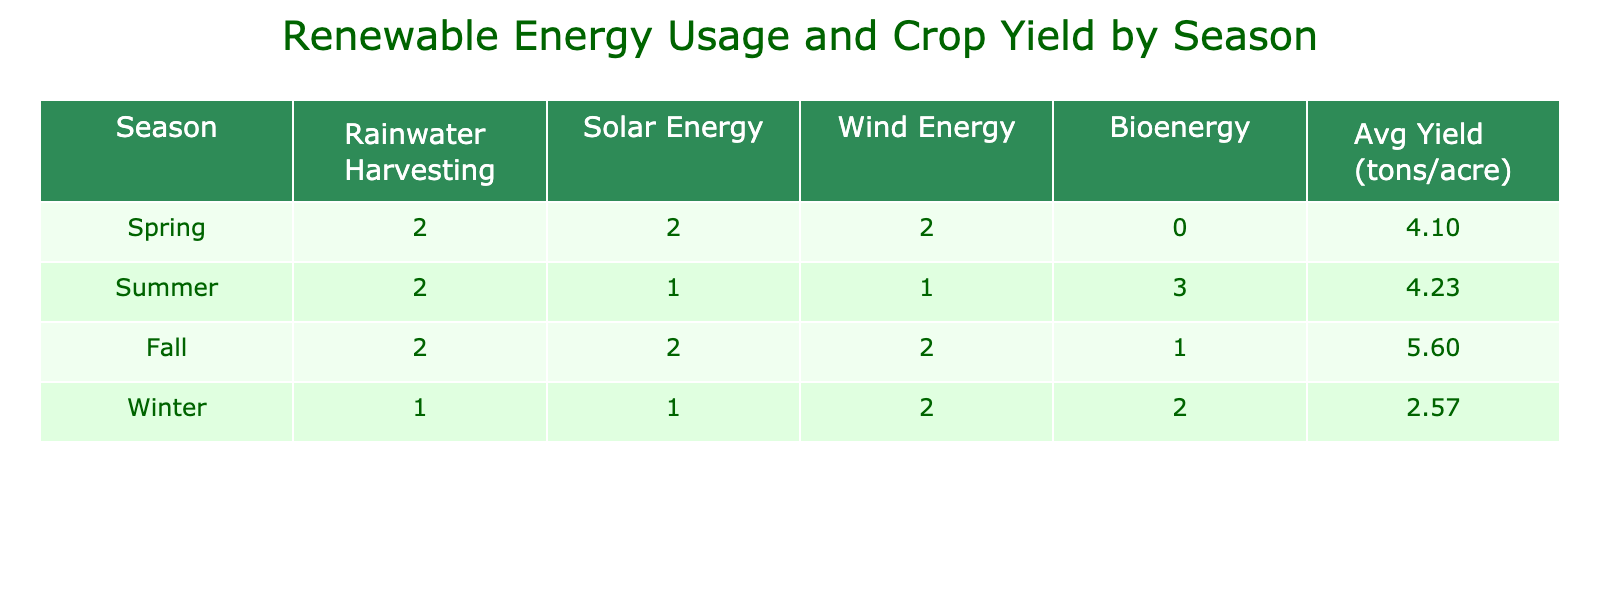What is the average crop yield in Spring? To find the average crop yield for Spring, we look at the crop yields for all Spring data points. The yields are 4.5, 3.8, and 4.0 tons per acre. Adding these values gives 4.5 + 3.8 + 4.0 = 12.3. Then, we divide by the number of data points (3) to find the average: 12.3 / 3 = 4.10.
Answer: 4.10 How many times was wind energy used in the Summer? To find the number of times wind energy was used in Summer, we examine the table for the Summer season. There are three data points for Summer: one with wind energy (in combination with other sources) and the other two without it. Thus, wind energy was used in just 1 combination, which is confirmed by checking each entry.
Answer: 1 Which season had the highest average crop yield? The average crop yields are calculated for each season: Spring (4.10), Summer (4.53), Fall (5.63), and Winter (2.57). Comparing these averages, Fall has the highest yield of 5.63 tons per acre, so it is the best season for crop yield.
Answer: Fall Did the use of solar energy contribute to a higher yield in Fall? In Fall, the crop yields for solar energy usage consist of two measurements: one with solar energy (5.3 tons per acre) and one without (5.5 tons per acre). Since both yields are high, it suggests that solar energy may stabilize yield, but the yield is higher without it, indicating mixed results. Thus, the presence of solar energy does not assure higher yields in Fall.
Answer: No What is the difference in average crop yield between Winter and Summer? The average yield for Winter is 2.57 and for Summer is 4.53. To find the difference, we subtract Winter's average from Summer's average: 4.53 - 2.57 = 1.96. Therefore, the difference in their average yields is significant, reflecting Summer's advantages over Winter conditions for crop production.
Answer: 1.96 In which season was rainwater harvesting not used? Looking at the data, in Winter there is no usage of rainwater harvesting; both entries for Winter indicate "No" for this source. Thus, we conclude that Winter is the season where rainwater harvesting was not utilized in any crop yield.
Answer: Winter How many different renewable energy sources were used in total during Fall? In Fall, there are three different renewable energy sources employed: Rainwater Harvesting, Solar Energy, and Wind Energy, with 'Yes' marked for each of these. Thus, the total unique renewable energy sources used in Fall amount to three, showcasing a combination of energy strategies.
Answer: 3 Was bioenergy used at all in Spring? Checking the Spring entries, we find that bioenergy is never marked with 'Yes'; all entries for Spring have 'No' for bioenergy. This confirms that bioenergy was not utilized during the Spring season for crop production whatsoever.
Answer: No 